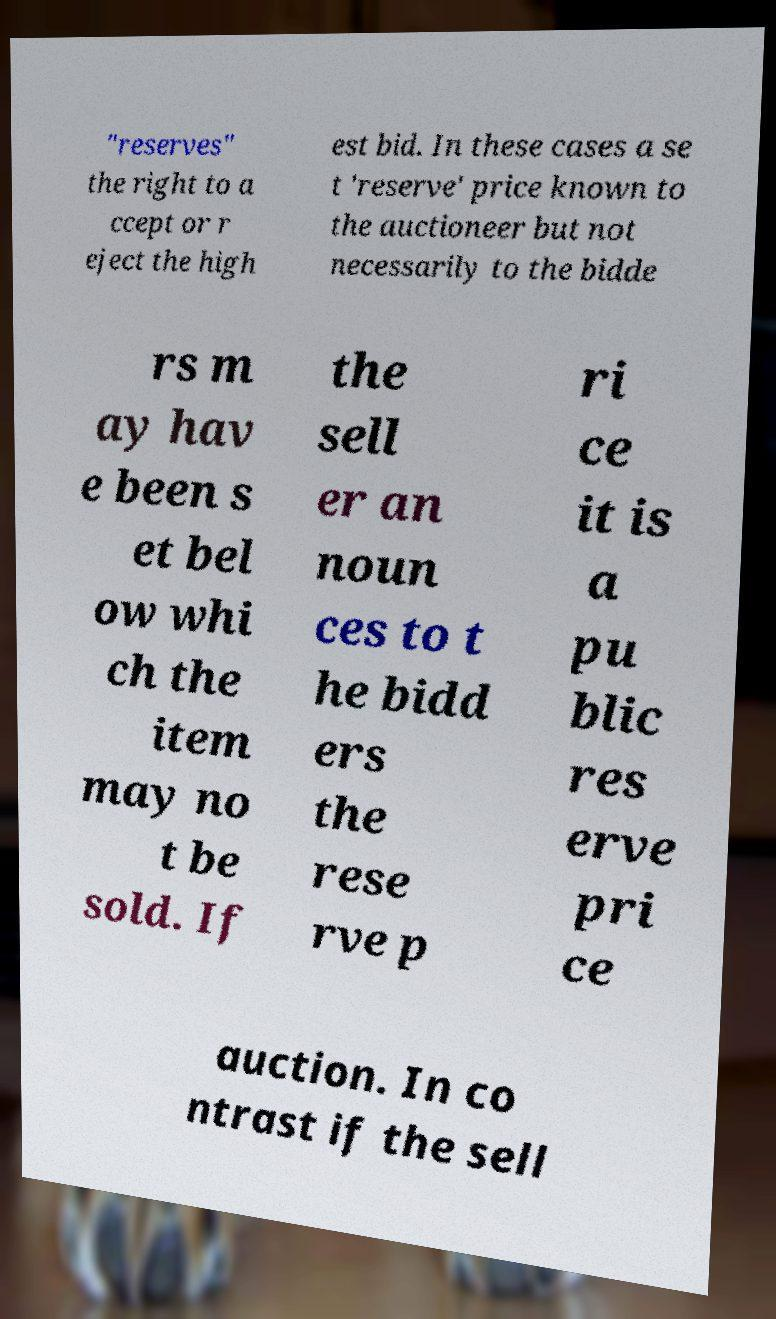Could you extract and type out the text from this image? "reserves" the right to a ccept or r eject the high est bid. In these cases a se t 'reserve' price known to the auctioneer but not necessarily to the bidde rs m ay hav e been s et bel ow whi ch the item may no t be sold. If the sell er an noun ces to t he bidd ers the rese rve p ri ce it is a pu blic res erve pri ce auction. In co ntrast if the sell 